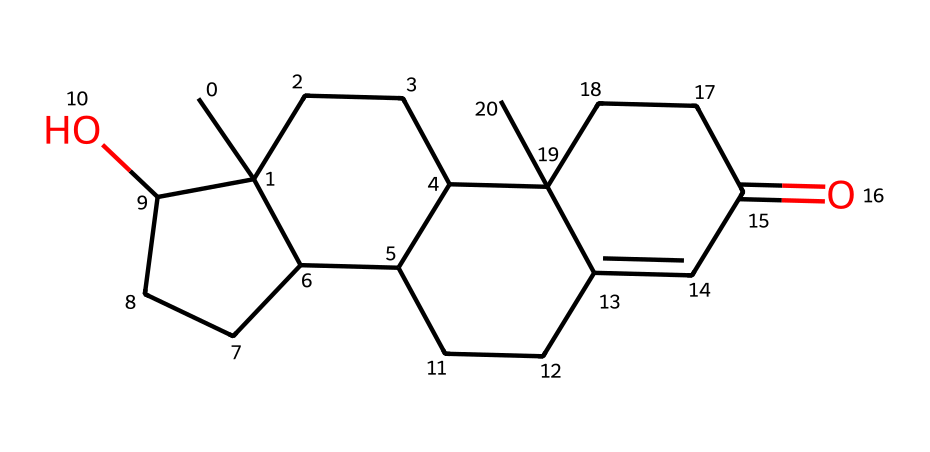What is the main functional group in testosterone? The structure of testosterone includes a hydroxyl group (OH) in the cyclohexane ring, indicating that it has alcohol characteristics. This is represented by the 'O' in the SMILES, linked to a carbon atom in the molecule.
Answer: hydroxyl group How many carbon atoms are present in testosterone? To determine the number of carbon atoms, we analyze the SMILES string and count each 'C' that denotes a carbon atom. By tallying them up, we find a total of 19 carbon atoms in the structure.
Answer: 19 What type of molecule is testosterone classified as? Testosterone is categorized as a steroid hormone due to its multi-ring structure typical of steroids, which is evident from the arrangement of carbon atoms forming four interconnected rings.
Answer: steroid How many rings are present in the structure of testosterone? Looking at the SMILES representation, we identify four cyclic structures or rings based on the way carbon atoms are interconnected. Each of these contributes to the overall ring count in the molecule.
Answer: four What is the degree of saturation for testosterone? The degree of saturation can be calculated by assessing the number of double bonds versus the number of hydrogens typically found in a saturated compound. Given the absence of any double bonds in the structure, it indicates a high level of saturation.
Answer: saturated What role does testosterone play in behavior? Testosterone is associated with the regulation of various behaviors, including aggression and risk-taking, due to its influence on neurotransmitters and brain regions involved in these behaviors.
Answer: risk-taking behavior 